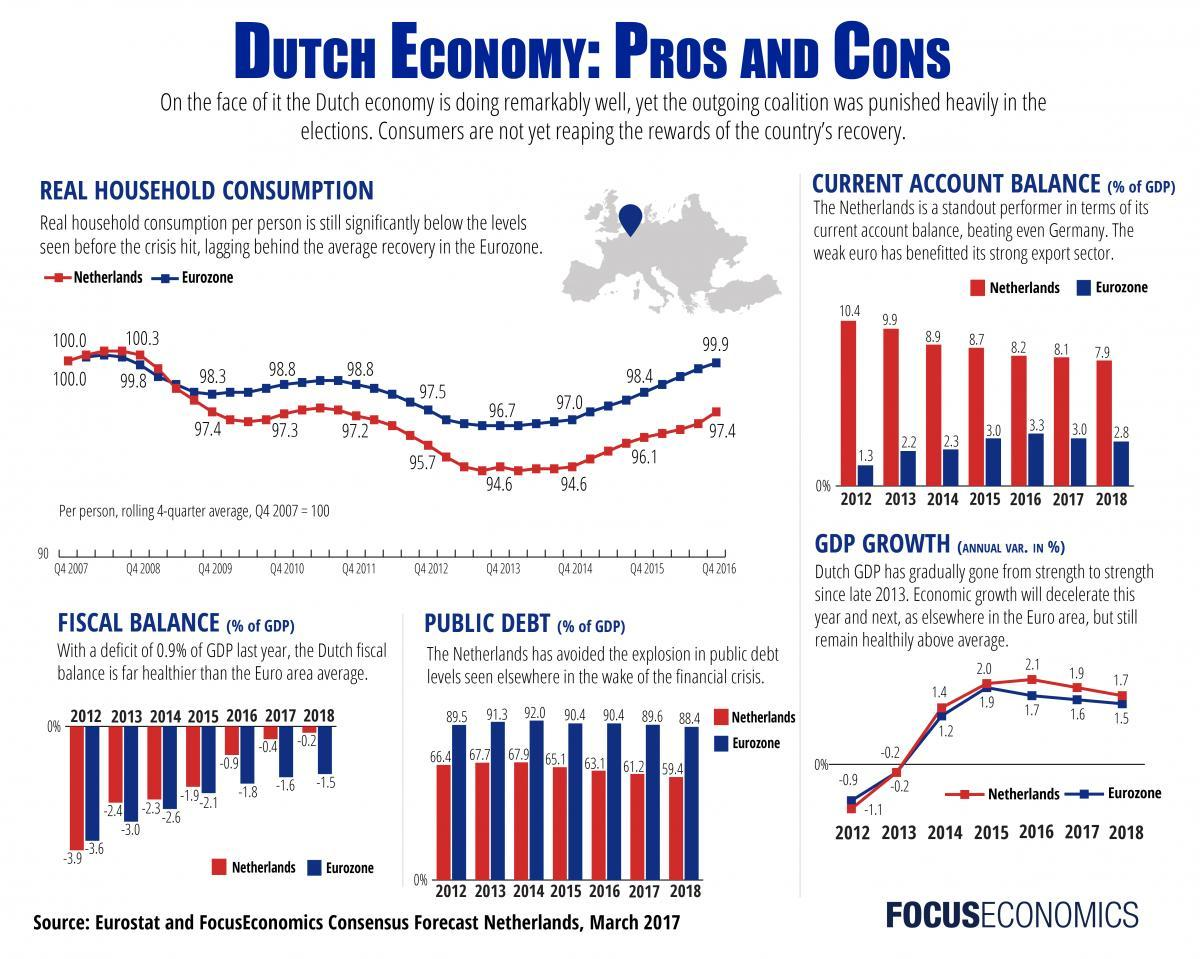What is the difference between public debt in the Eurozone and the Netherlands in 2012?
Answer the question with a short phrase. 23.1 What is the difference between the fiscal balance in the Netherlands and the Eurozone in 2012? -0.3 What is the difference between the current account balance in the Netherlands and the Eurozone in 2012? 9.1 